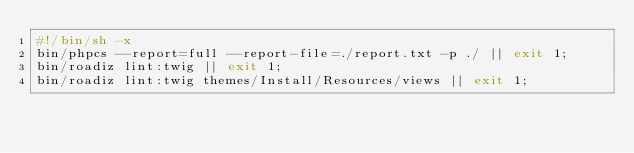Convert code to text. <code><loc_0><loc_0><loc_500><loc_500><_Bash_>#!/bin/sh -x
bin/phpcs --report=full --report-file=./report.txt -p ./ || exit 1;
bin/roadiz lint:twig || exit 1;
bin/roadiz lint:twig themes/Install/Resources/views || exit 1;
</code> 